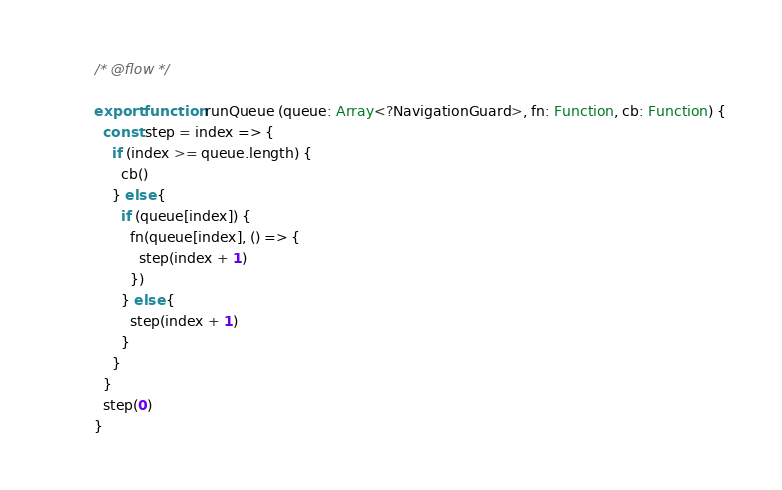Convert code to text. <code><loc_0><loc_0><loc_500><loc_500><_JavaScript_>/* @flow */

export function runQueue (queue: Array<?NavigationGuard>, fn: Function, cb: Function) {
  const step = index => {
    if (index >= queue.length) {
      cb()
    } else {
      if (queue[index]) {
        fn(queue[index], () => {
          step(index + 1)
        })
      } else {
        step(index + 1)
      }
    }
  }
  step(0)
}
</code> 